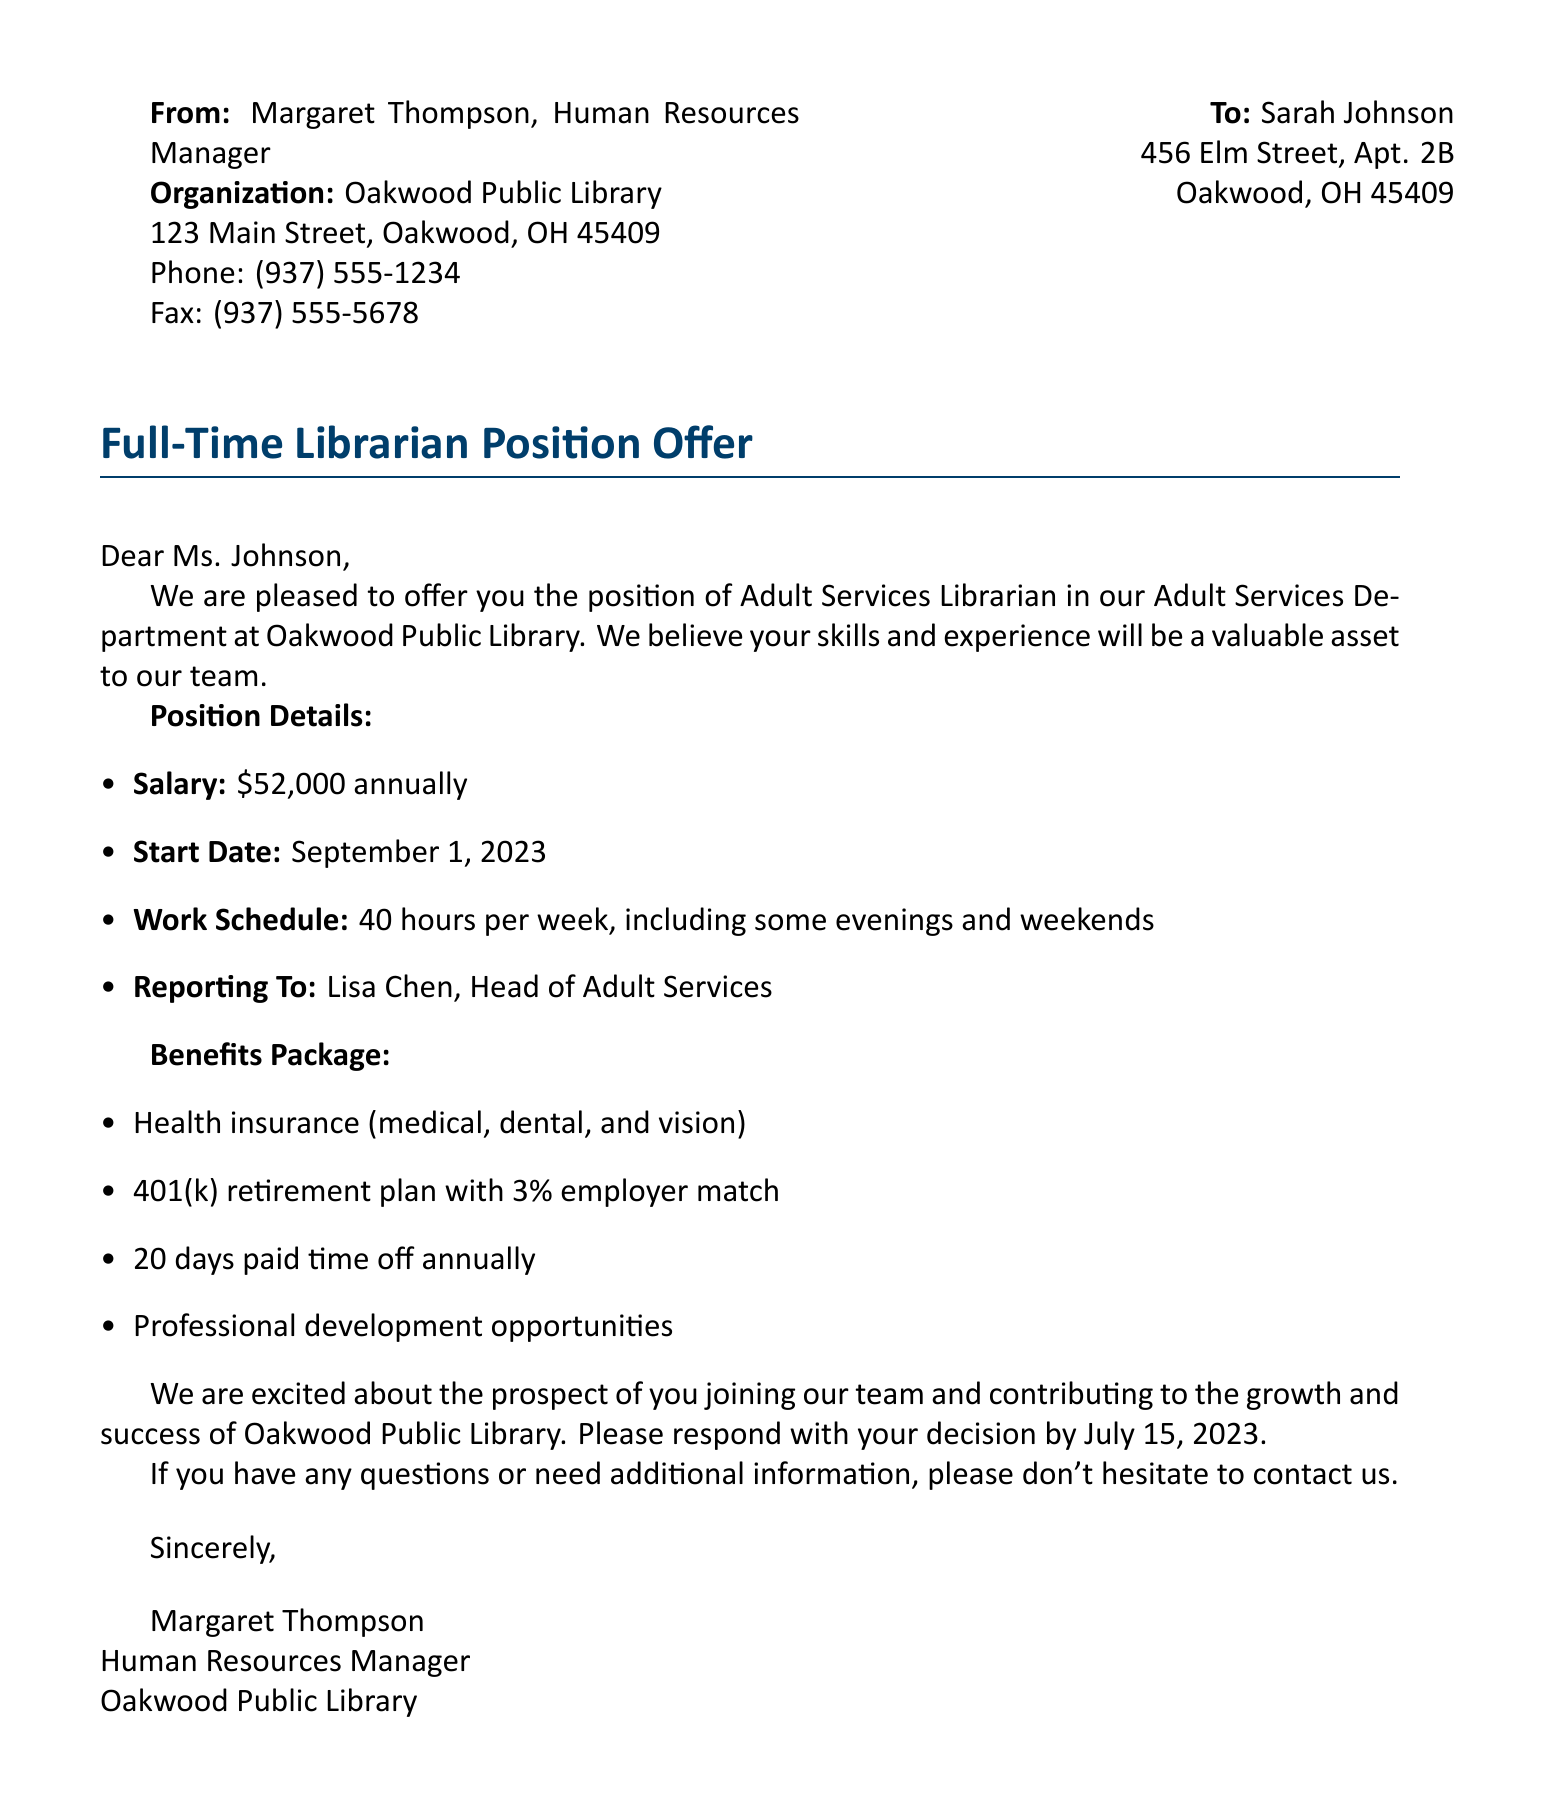What is the position title? The position title stated in the document is "Adult Services Librarian."
Answer: Adult Services Librarian What is the annual salary offered? The annual salary mentioned for the position is $52,000.
Answer: $52,000 When is the start date for the job? The start date for the position is indicated in the document as September 1, 2023.
Answer: September 1, 2023 What type of benefits are included in the package? The document lists benefits including health insurance, retirement plan, paid time off, and professional development.
Answer: Health insurance, 401(k), paid time off, professional development Who is the hiring manager? The hiring manager mentioned in the document is named Margaret Thompson.
Answer: Margaret Thompson How many days of paid time off are offered annually? The document states that there are 20 days of paid time off annually.
Answer: 20 days What is the reporting structure for the position? The individual will report to Lisa Chen, according to the document.
Answer: Lisa Chen What is the deadline to respond to the job offer? The document specifies that the response is needed by July 15, 2023.
Answer: July 15, 2023 What is the expected work schedule? The expected work schedule is described as 40 hours per week, including some evenings and weekends.
Answer: 40 hours per week, including some evenings and weekends 